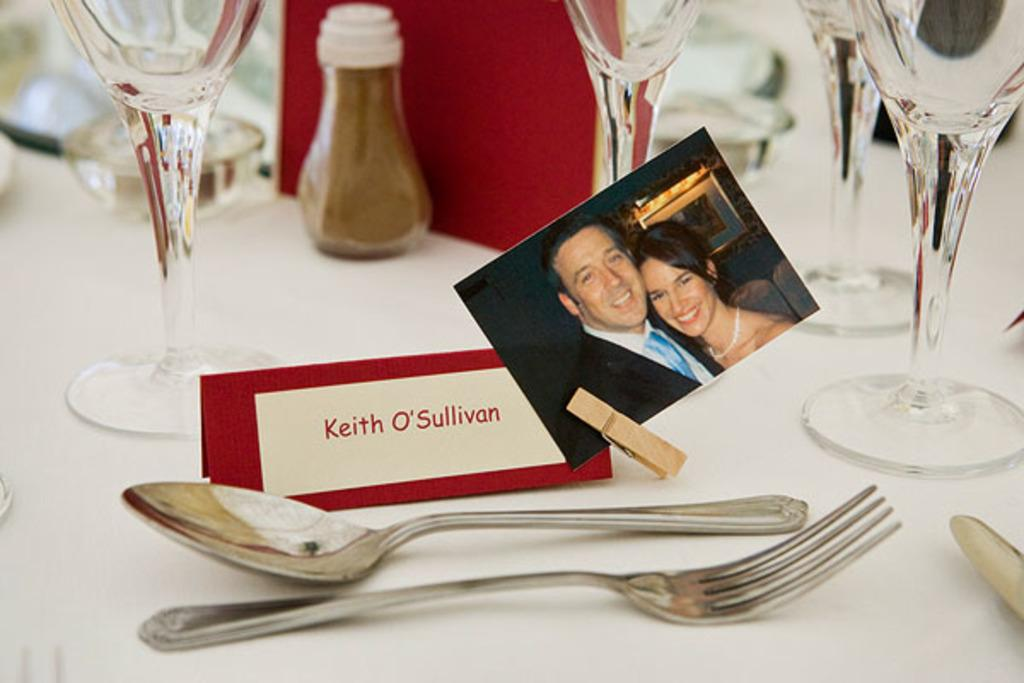What is the main piece of furniture in the image? There is a table in the image. What is covering the table? The table is covered with a white cloth. What type of dishware is on the table? There is a glass on the table. What is used for writing on the table? There is a name board on the table. What utensils are on the table? There is a spoon and a fork on the table. What is the purpose of the photo on the table? The purpose of the photo on the table is not specified, but it could be for decoration or to represent a memory. What type of quartz is used as a centerpiece on the table in the image? There is no quartz present in the image; the table is covered with a white cloth and has various items on it, but no quartz. 